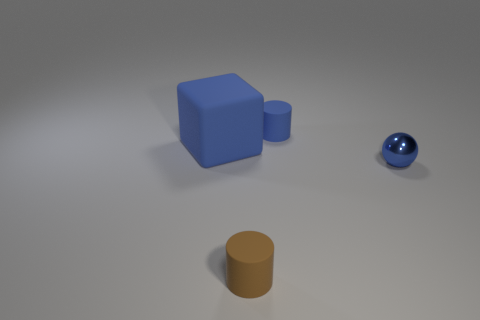Do the brown rubber cylinder and the blue cube have the same size?
Keep it short and to the point. No. Do the tiny brown matte object and the small blue rubber object have the same shape?
Keep it short and to the point. Yes. There is a tiny blue object in front of the big matte block; what is it made of?
Give a very brief answer. Metal. What color is the large matte thing?
Make the answer very short. Blue. There is a matte object that is in front of the tiny blue ball; does it have the same size as the blue thing that is on the right side of the small blue cylinder?
Provide a succinct answer. Yes. What is the size of the blue thing that is both to the right of the brown cylinder and left of the tiny blue sphere?
Keep it short and to the point. Small. There is another small object that is the same shape as the small brown matte thing; what color is it?
Your response must be concise. Blue. Are there more large blue objects that are behind the tiny shiny sphere than large blue matte things right of the large blue matte object?
Keep it short and to the point. Yes. What number of other objects are the same shape as the large thing?
Offer a very short reply. 0. Are there any small matte things that are behind the cylinder in front of the tiny metallic ball?
Offer a terse response. Yes. 